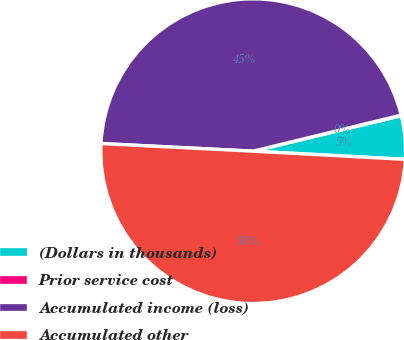<chart> <loc_0><loc_0><loc_500><loc_500><pie_chart><fcel>(Dollars in thousands)<fcel>Prior service cost<fcel>Accumulated income (loss)<fcel>Accumulated other<nl><fcel>4.6%<fcel>0.06%<fcel>45.4%<fcel>49.94%<nl></chart> 